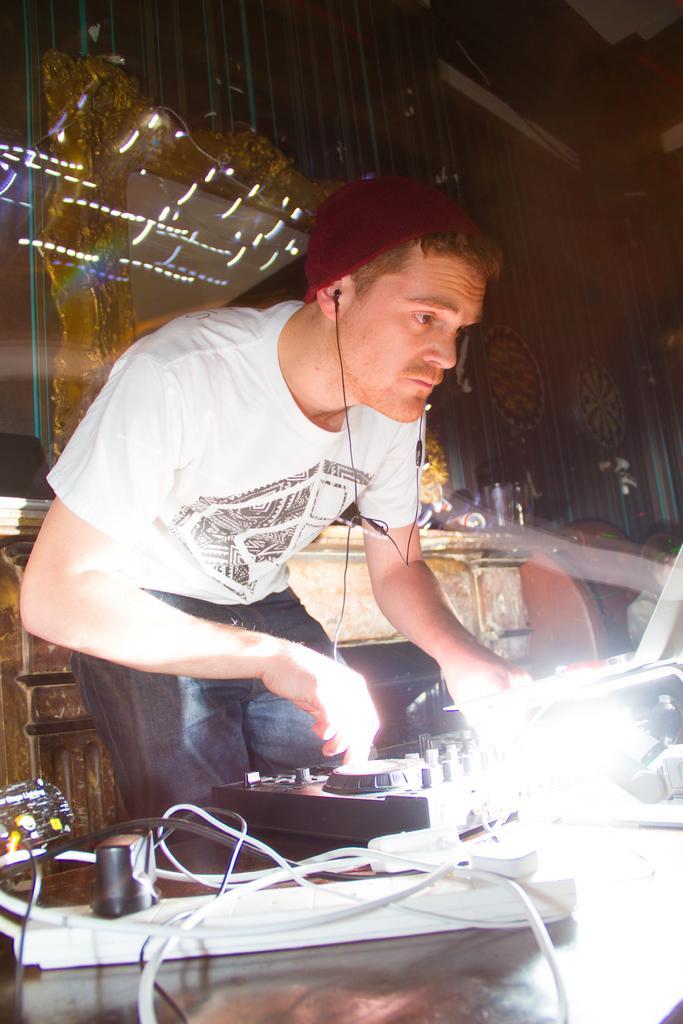How would you summarize this image in a sentence or two? In this image I see a man who is wearing white t-shirt and I see he is wearing a cap on his head and I see the electronic equipment over here and I see the wires and I see the light over here and I see that this man is standing. 